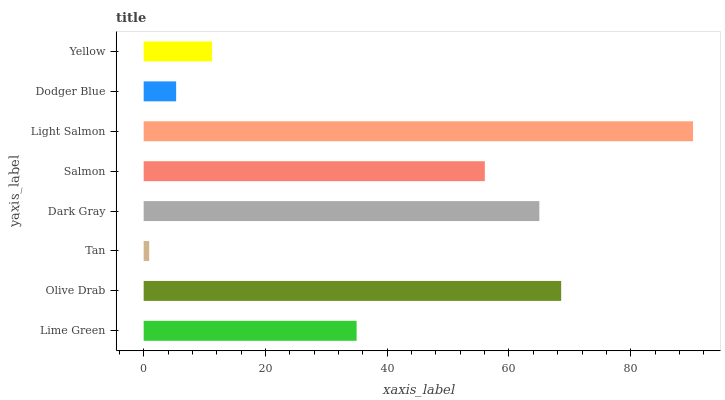Is Tan the minimum?
Answer yes or no. Yes. Is Light Salmon the maximum?
Answer yes or no. Yes. Is Olive Drab the minimum?
Answer yes or no. No. Is Olive Drab the maximum?
Answer yes or no. No. Is Olive Drab greater than Lime Green?
Answer yes or no. Yes. Is Lime Green less than Olive Drab?
Answer yes or no. Yes. Is Lime Green greater than Olive Drab?
Answer yes or no. No. Is Olive Drab less than Lime Green?
Answer yes or no. No. Is Salmon the high median?
Answer yes or no. Yes. Is Lime Green the low median?
Answer yes or no. Yes. Is Lime Green the high median?
Answer yes or no. No. Is Tan the low median?
Answer yes or no. No. 